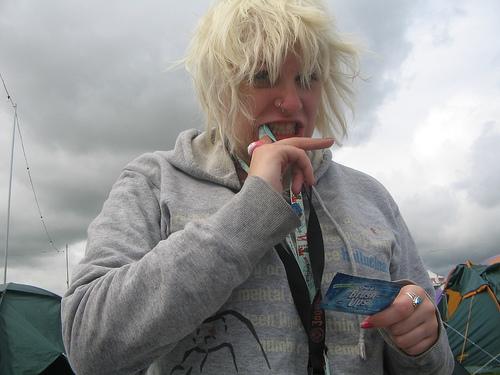What is this lady eating?
Answer briefly. Gum. What face piercing does this lady have?
Short answer required. Nose ring. Is it sunny?
Short answer required. No. Is this girl's hair a natural color?
Answer briefly. No. 